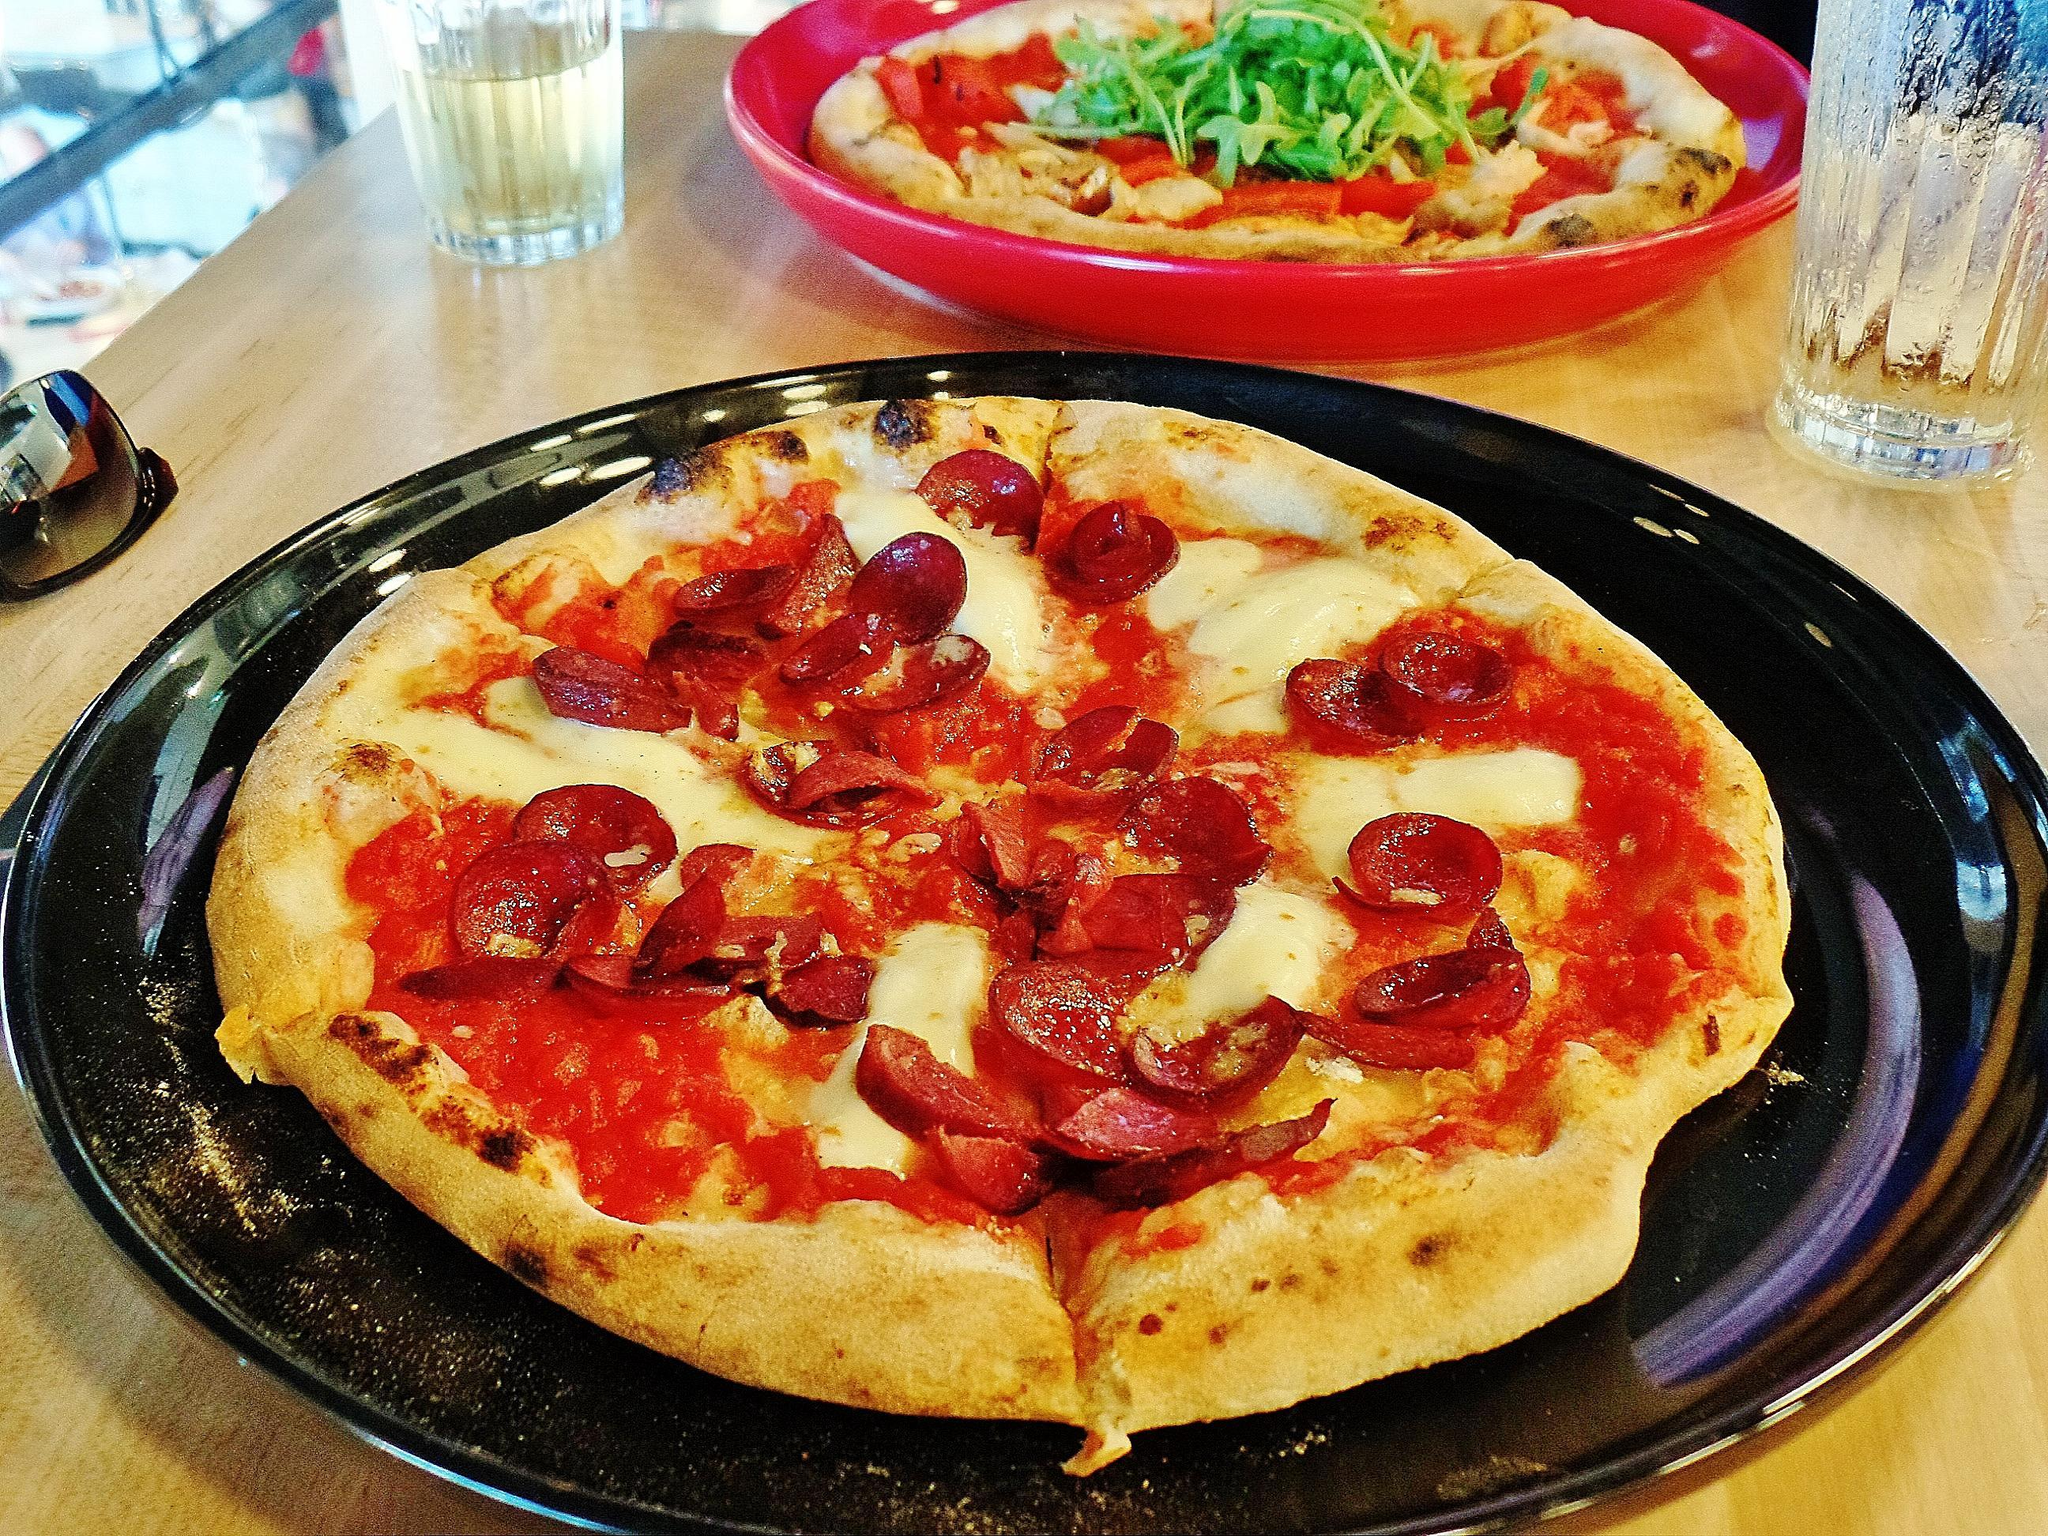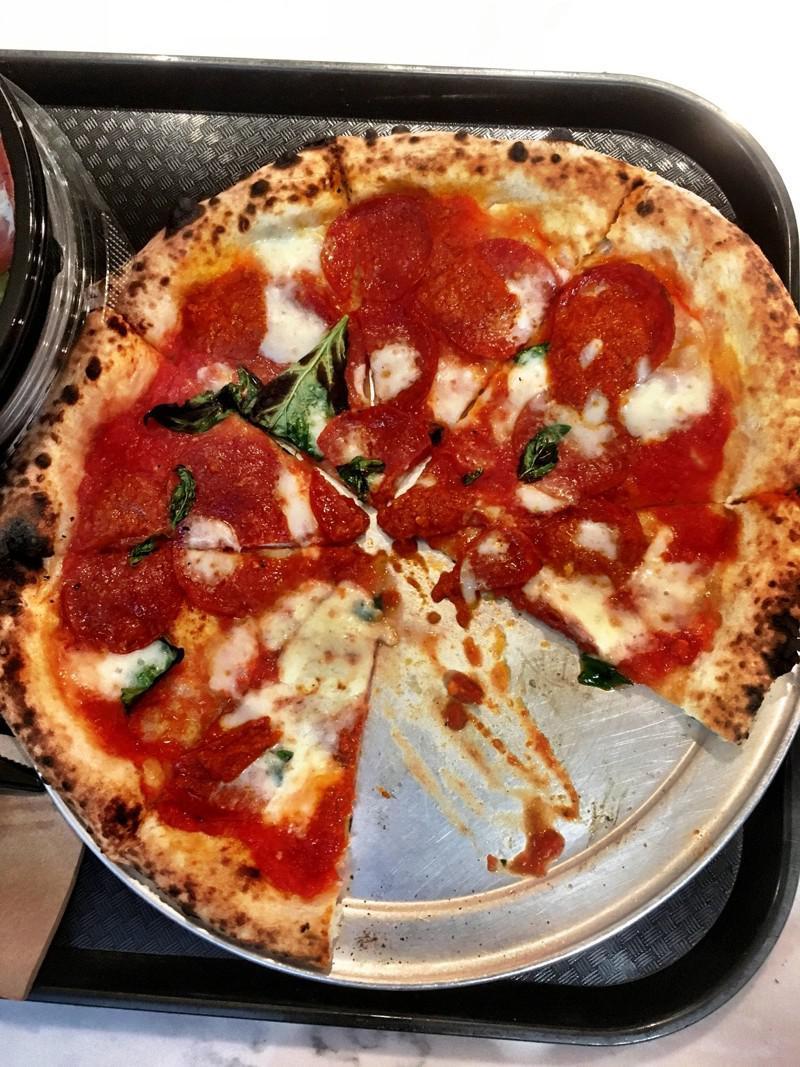The first image is the image on the left, the second image is the image on the right. Given the left and right images, does the statement "A whole cooked pizza is on a white plate." hold true? Answer yes or no. No. The first image is the image on the left, the second image is the image on the right. Given the left and right images, does the statement "In at least one image the is a small piece of pizza with toppings sit on top of a circle white plate." hold true? Answer yes or no. No. 